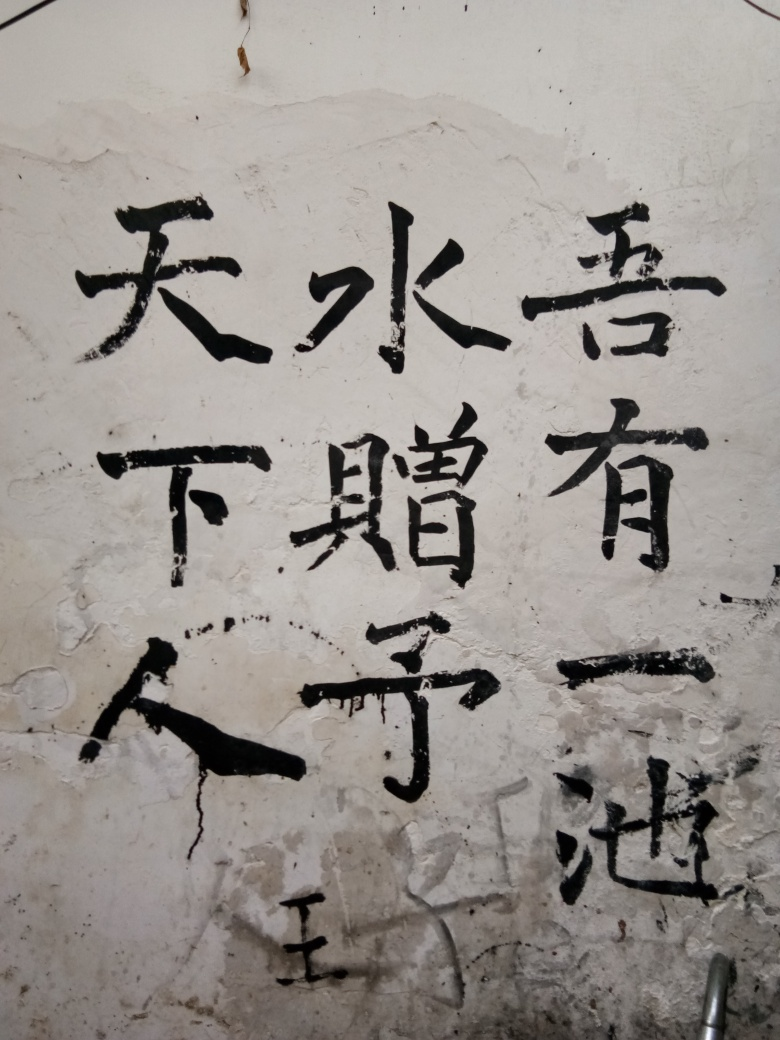Can you describe the style or significance of the characters written on the wall? The characters are executed in a style that suggests a blend of calligraphy and graffiti. Though I can't translate or interpret the exact meaning, they hold a visual significance, conveying a message or a statement with a sense of urgency and informality, as if the author aimed to communicate quickly while still retaining an element of artistic flair. 